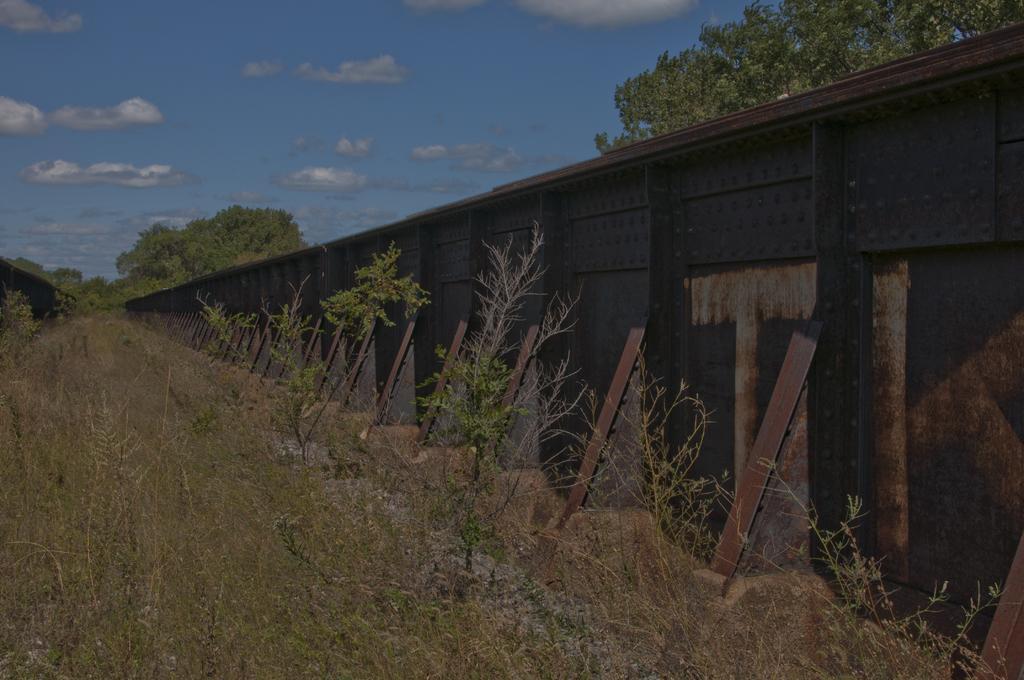Could you give a brief overview of what you see in this image? In this image there is a bridge. There are plants and trees in the background. The sky is cloudy. 